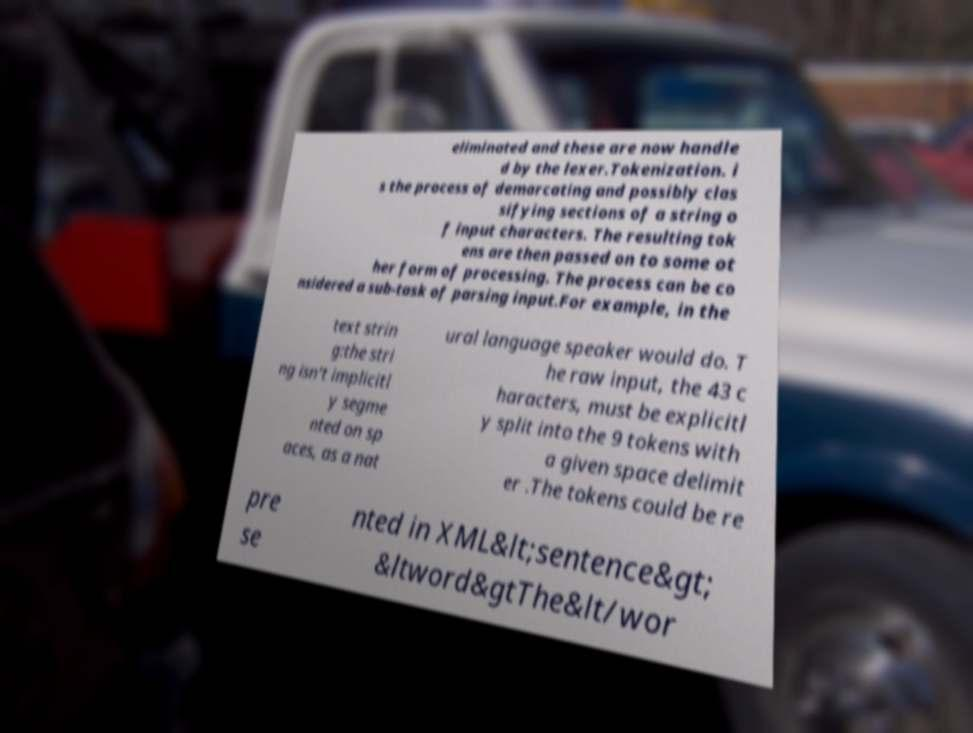Could you assist in decoding the text presented in this image and type it out clearly? eliminated and these are now handle d by the lexer.Tokenization. i s the process of demarcating and possibly clas sifying sections of a string o f input characters. The resulting tok ens are then passed on to some ot her form of processing. The process can be co nsidered a sub-task of parsing input.For example, in the text strin g:the stri ng isn't implicitl y segme nted on sp aces, as a nat ural language speaker would do. T he raw input, the 43 c haracters, must be explicitl y split into the 9 tokens with a given space delimit er .The tokens could be re pre se nted in XML&lt;sentence&gt; &ltword&gtThe&lt/wor 